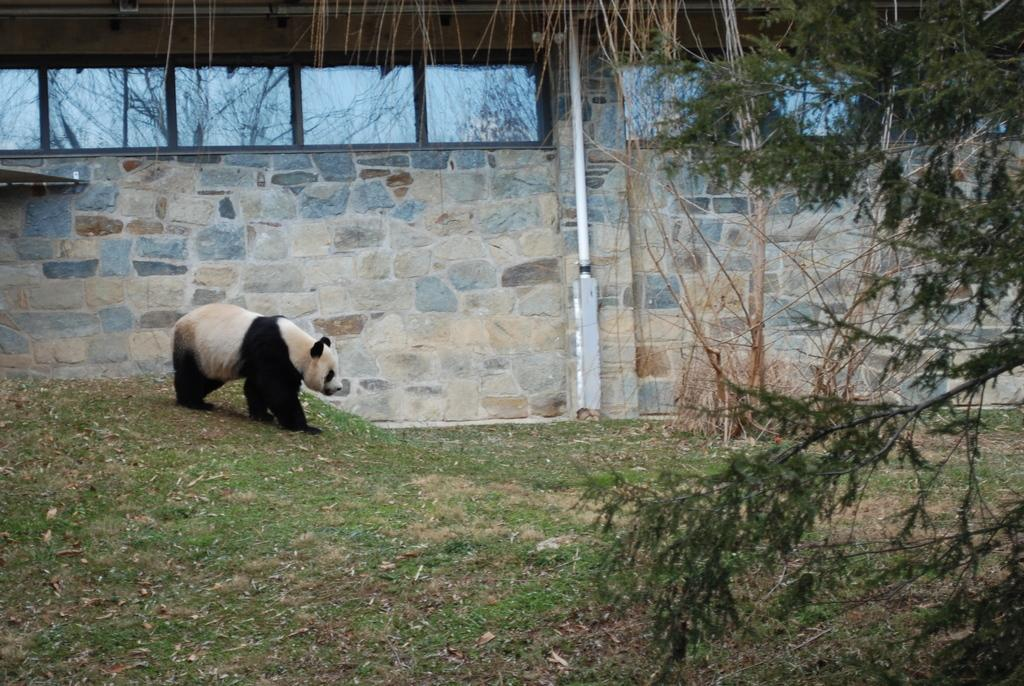What animal is the main subject of the image? There is a panda in the image. What is the panda doing in the image? The panda is standing on the ground. What can be seen in the background of the image? There are trees, a wall, grass, and other objects visible in the background of the image. What is the panda's level of anger in the image? There is no indication of the panda's emotional state in the image, so we cannot determine its level of anger. Is there a sink visible in the image? No, there is no sink present in the image. 